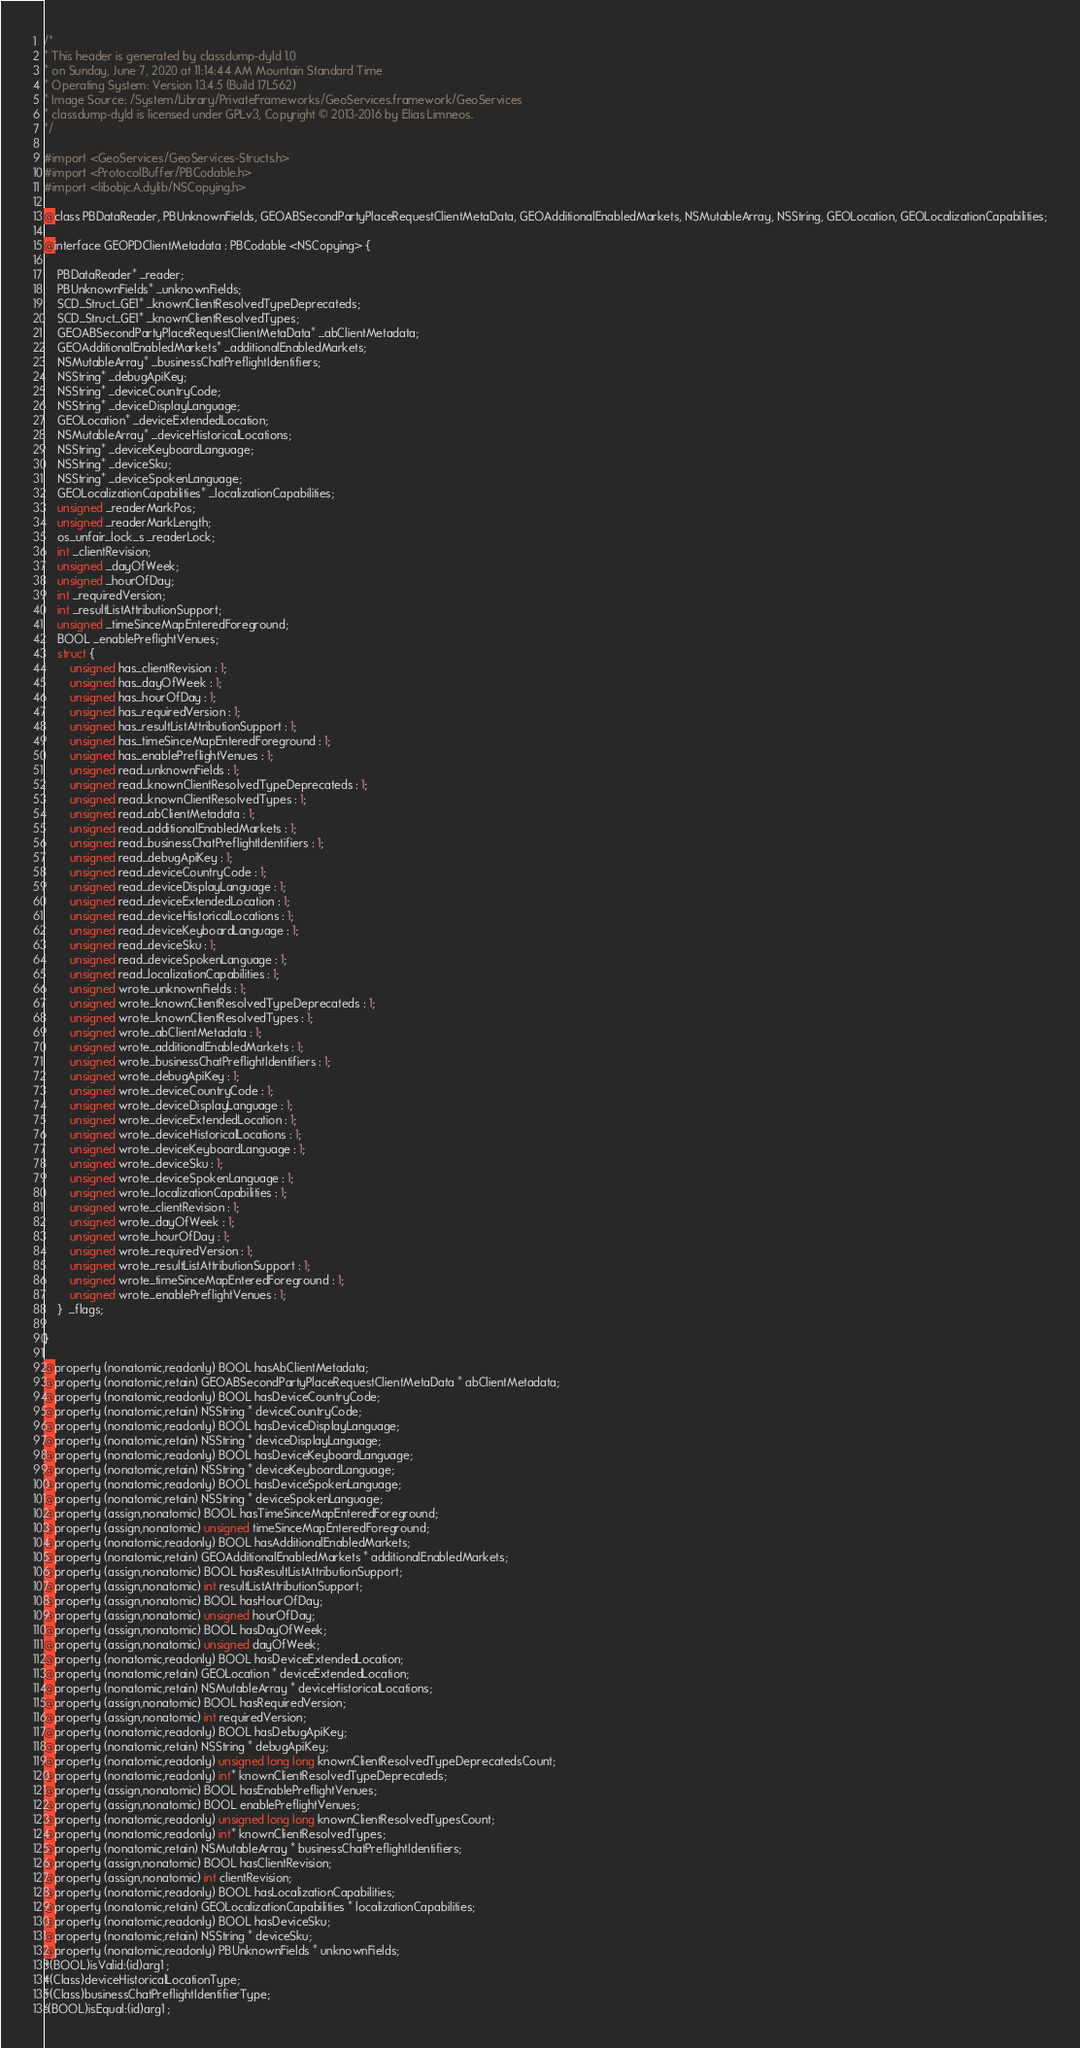<code> <loc_0><loc_0><loc_500><loc_500><_C_>/*
* This header is generated by classdump-dyld 1.0
* on Sunday, June 7, 2020 at 11:14:44 AM Mountain Standard Time
* Operating System: Version 13.4.5 (Build 17L562)
* Image Source: /System/Library/PrivateFrameworks/GeoServices.framework/GeoServices
* classdump-dyld is licensed under GPLv3, Copyright © 2013-2016 by Elias Limneos.
*/

#import <GeoServices/GeoServices-Structs.h>
#import <ProtocolBuffer/PBCodable.h>
#import <libobjc.A.dylib/NSCopying.h>

@class PBDataReader, PBUnknownFields, GEOABSecondPartyPlaceRequestClientMetaData, GEOAdditionalEnabledMarkets, NSMutableArray, NSString, GEOLocation, GEOLocalizationCapabilities;

@interface GEOPDClientMetadata : PBCodable <NSCopying> {

	PBDataReader* _reader;
	PBUnknownFields* _unknownFields;
	SCD_Struct_GE1* _knownClientResolvedTypeDeprecateds;
	SCD_Struct_GE1* _knownClientResolvedTypes;
	GEOABSecondPartyPlaceRequestClientMetaData* _abClientMetadata;
	GEOAdditionalEnabledMarkets* _additionalEnabledMarkets;
	NSMutableArray* _businessChatPreflightIdentifiers;
	NSString* _debugApiKey;
	NSString* _deviceCountryCode;
	NSString* _deviceDisplayLanguage;
	GEOLocation* _deviceExtendedLocation;
	NSMutableArray* _deviceHistoricalLocations;
	NSString* _deviceKeyboardLanguage;
	NSString* _deviceSku;
	NSString* _deviceSpokenLanguage;
	GEOLocalizationCapabilities* _localizationCapabilities;
	unsigned _readerMarkPos;
	unsigned _readerMarkLength;
	os_unfair_lock_s _readerLock;
	int _clientRevision;
	unsigned _dayOfWeek;
	unsigned _hourOfDay;
	int _requiredVersion;
	int _resultListAttributionSupport;
	unsigned _timeSinceMapEnteredForeground;
	BOOL _enablePreflightVenues;
	struct {
		unsigned has_clientRevision : 1;
		unsigned has_dayOfWeek : 1;
		unsigned has_hourOfDay : 1;
		unsigned has_requiredVersion : 1;
		unsigned has_resultListAttributionSupport : 1;
		unsigned has_timeSinceMapEnteredForeground : 1;
		unsigned has_enablePreflightVenues : 1;
		unsigned read_unknownFields : 1;
		unsigned read_knownClientResolvedTypeDeprecateds : 1;
		unsigned read_knownClientResolvedTypes : 1;
		unsigned read_abClientMetadata : 1;
		unsigned read_additionalEnabledMarkets : 1;
		unsigned read_businessChatPreflightIdentifiers : 1;
		unsigned read_debugApiKey : 1;
		unsigned read_deviceCountryCode : 1;
		unsigned read_deviceDisplayLanguage : 1;
		unsigned read_deviceExtendedLocation : 1;
		unsigned read_deviceHistoricalLocations : 1;
		unsigned read_deviceKeyboardLanguage : 1;
		unsigned read_deviceSku : 1;
		unsigned read_deviceSpokenLanguage : 1;
		unsigned read_localizationCapabilities : 1;
		unsigned wrote_unknownFields : 1;
		unsigned wrote_knownClientResolvedTypeDeprecateds : 1;
		unsigned wrote_knownClientResolvedTypes : 1;
		unsigned wrote_abClientMetadata : 1;
		unsigned wrote_additionalEnabledMarkets : 1;
		unsigned wrote_businessChatPreflightIdentifiers : 1;
		unsigned wrote_debugApiKey : 1;
		unsigned wrote_deviceCountryCode : 1;
		unsigned wrote_deviceDisplayLanguage : 1;
		unsigned wrote_deviceExtendedLocation : 1;
		unsigned wrote_deviceHistoricalLocations : 1;
		unsigned wrote_deviceKeyboardLanguage : 1;
		unsigned wrote_deviceSku : 1;
		unsigned wrote_deviceSpokenLanguage : 1;
		unsigned wrote_localizationCapabilities : 1;
		unsigned wrote_clientRevision : 1;
		unsigned wrote_dayOfWeek : 1;
		unsigned wrote_hourOfDay : 1;
		unsigned wrote_requiredVersion : 1;
		unsigned wrote_resultListAttributionSupport : 1;
		unsigned wrote_timeSinceMapEnteredForeground : 1;
		unsigned wrote_enablePreflightVenues : 1;
	}  _flags;

}

@property (nonatomic,readonly) BOOL hasAbClientMetadata; 
@property (nonatomic,retain) GEOABSecondPartyPlaceRequestClientMetaData * abClientMetadata; 
@property (nonatomic,readonly) BOOL hasDeviceCountryCode; 
@property (nonatomic,retain) NSString * deviceCountryCode; 
@property (nonatomic,readonly) BOOL hasDeviceDisplayLanguage; 
@property (nonatomic,retain) NSString * deviceDisplayLanguage; 
@property (nonatomic,readonly) BOOL hasDeviceKeyboardLanguage; 
@property (nonatomic,retain) NSString * deviceKeyboardLanguage; 
@property (nonatomic,readonly) BOOL hasDeviceSpokenLanguage; 
@property (nonatomic,retain) NSString * deviceSpokenLanguage; 
@property (assign,nonatomic) BOOL hasTimeSinceMapEnteredForeground; 
@property (assign,nonatomic) unsigned timeSinceMapEnteredForeground; 
@property (nonatomic,readonly) BOOL hasAdditionalEnabledMarkets; 
@property (nonatomic,retain) GEOAdditionalEnabledMarkets * additionalEnabledMarkets; 
@property (assign,nonatomic) BOOL hasResultListAttributionSupport; 
@property (assign,nonatomic) int resultListAttributionSupport; 
@property (assign,nonatomic) BOOL hasHourOfDay; 
@property (assign,nonatomic) unsigned hourOfDay; 
@property (assign,nonatomic) BOOL hasDayOfWeek; 
@property (assign,nonatomic) unsigned dayOfWeek; 
@property (nonatomic,readonly) BOOL hasDeviceExtendedLocation; 
@property (nonatomic,retain) GEOLocation * deviceExtendedLocation; 
@property (nonatomic,retain) NSMutableArray * deviceHistoricalLocations; 
@property (assign,nonatomic) BOOL hasRequiredVersion; 
@property (assign,nonatomic) int requiredVersion; 
@property (nonatomic,readonly) BOOL hasDebugApiKey; 
@property (nonatomic,retain) NSString * debugApiKey; 
@property (nonatomic,readonly) unsigned long long knownClientResolvedTypeDeprecatedsCount; 
@property (nonatomic,readonly) int* knownClientResolvedTypeDeprecateds; 
@property (assign,nonatomic) BOOL hasEnablePreflightVenues; 
@property (assign,nonatomic) BOOL enablePreflightVenues; 
@property (nonatomic,readonly) unsigned long long knownClientResolvedTypesCount; 
@property (nonatomic,readonly) int* knownClientResolvedTypes; 
@property (nonatomic,retain) NSMutableArray * businessChatPreflightIdentifiers; 
@property (assign,nonatomic) BOOL hasClientRevision; 
@property (assign,nonatomic) int clientRevision; 
@property (nonatomic,readonly) BOOL hasLocalizationCapabilities; 
@property (nonatomic,retain) GEOLocalizationCapabilities * localizationCapabilities; 
@property (nonatomic,readonly) BOOL hasDeviceSku; 
@property (nonatomic,retain) NSString * deviceSku; 
@property (nonatomic,readonly) PBUnknownFields * unknownFields; 
+(BOOL)isValid:(id)arg1 ;
+(Class)deviceHistoricalLocationType;
+(Class)businessChatPreflightIdentifierType;
-(BOOL)isEqual:(id)arg1 ;</code> 